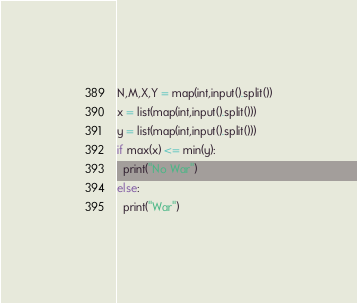<code> <loc_0><loc_0><loc_500><loc_500><_Python_>N,M,X,Y = map(int,input().split())
x = list(map(int,input().split()))
y = list(map(int,input().split()))
if max(x) <= min(y):
  print("No War")
else:
  print("War")</code> 